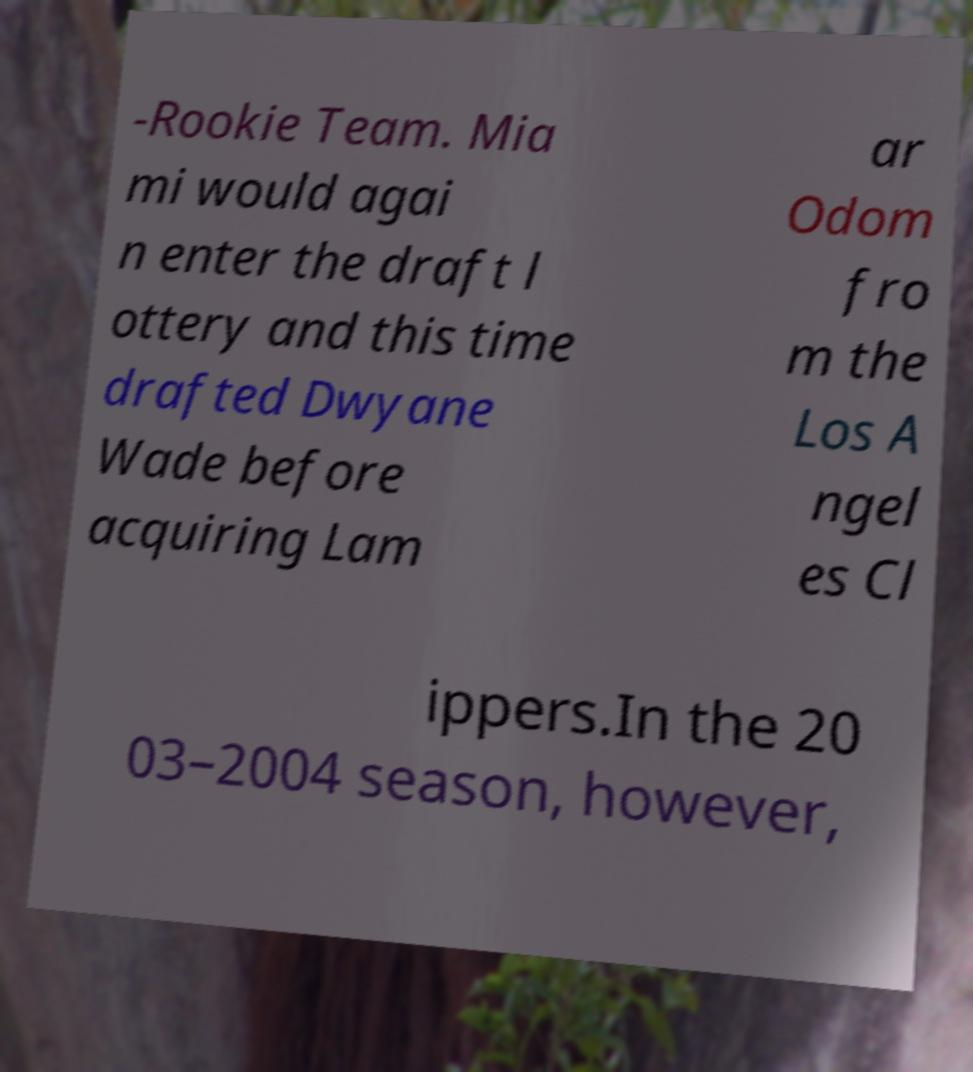There's text embedded in this image that I need extracted. Can you transcribe it verbatim? -Rookie Team. Mia mi would agai n enter the draft l ottery and this time drafted Dwyane Wade before acquiring Lam ar Odom fro m the Los A ngel es Cl ippers.In the 20 03–2004 season, however, 